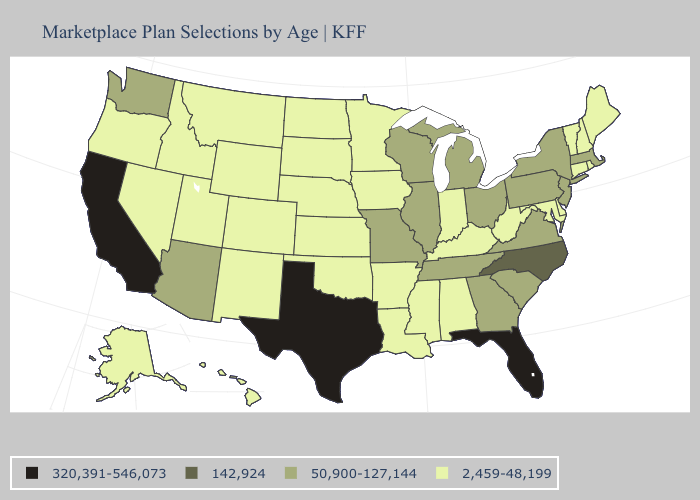Which states have the lowest value in the West?
Quick response, please. Alaska, Colorado, Hawaii, Idaho, Montana, Nevada, New Mexico, Oregon, Utah, Wyoming. What is the lowest value in states that border Washington?
Short answer required. 2,459-48,199. Name the states that have a value in the range 142,924?
Write a very short answer. North Carolina. Is the legend a continuous bar?
Quick response, please. No. Name the states that have a value in the range 2,459-48,199?
Keep it brief. Alabama, Alaska, Arkansas, Colorado, Connecticut, Delaware, Hawaii, Idaho, Indiana, Iowa, Kansas, Kentucky, Louisiana, Maine, Maryland, Minnesota, Mississippi, Montana, Nebraska, Nevada, New Hampshire, New Mexico, North Dakota, Oklahoma, Oregon, Rhode Island, South Dakota, Utah, Vermont, West Virginia, Wyoming. Does the map have missing data?
Give a very brief answer. No. Among the states that border Mississippi , does Tennessee have the lowest value?
Give a very brief answer. No. Among the states that border Montana , which have the lowest value?
Short answer required. Idaho, North Dakota, South Dakota, Wyoming. Name the states that have a value in the range 2,459-48,199?
Give a very brief answer. Alabama, Alaska, Arkansas, Colorado, Connecticut, Delaware, Hawaii, Idaho, Indiana, Iowa, Kansas, Kentucky, Louisiana, Maine, Maryland, Minnesota, Mississippi, Montana, Nebraska, Nevada, New Hampshire, New Mexico, North Dakota, Oklahoma, Oregon, Rhode Island, South Dakota, Utah, Vermont, West Virginia, Wyoming. What is the lowest value in the South?
Be succinct. 2,459-48,199. Which states have the lowest value in the West?
Short answer required. Alaska, Colorado, Hawaii, Idaho, Montana, Nevada, New Mexico, Oregon, Utah, Wyoming. Name the states that have a value in the range 320,391-546,073?
Be succinct. California, Florida, Texas. Among the states that border Kansas , does Missouri have the highest value?
Answer briefly. Yes. What is the value of Hawaii?
Give a very brief answer. 2,459-48,199. What is the lowest value in the South?
Short answer required. 2,459-48,199. 